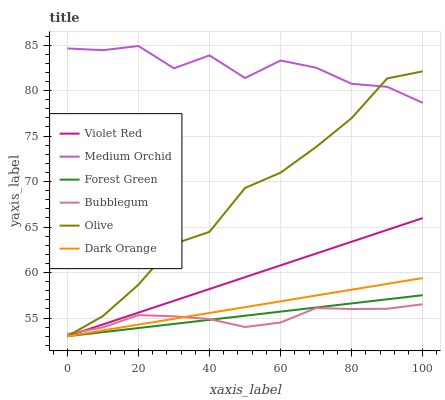Does Bubblegum have the minimum area under the curve?
Answer yes or no. Yes. Does Medium Orchid have the maximum area under the curve?
Answer yes or no. Yes. Does Violet Red have the minimum area under the curve?
Answer yes or no. No. Does Violet Red have the maximum area under the curve?
Answer yes or no. No. Is Violet Red the smoothest?
Answer yes or no. Yes. Is Medium Orchid the roughest?
Answer yes or no. Yes. Is Medium Orchid the smoothest?
Answer yes or no. No. Is Violet Red the roughest?
Answer yes or no. No. Does Dark Orange have the lowest value?
Answer yes or no. Yes. Does Medium Orchid have the lowest value?
Answer yes or no. No. Does Medium Orchid have the highest value?
Answer yes or no. Yes. Does Violet Red have the highest value?
Answer yes or no. No. Is Forest Green less than Medium Orchid?
Answer yes or no. Yes. Is Medium Orchid greater than Violet Red?
Answer yes or no. Yes. Does Olive intersect Forest Green?
Answer yes or no. Yes. Is Olive less than Forest Green?
Answer yes or no. No. Is Olive greater than Forest Green?
Answer yes or no. No. Does Forest Green intersect Medium Orchid?
Answer yes or no. No. 